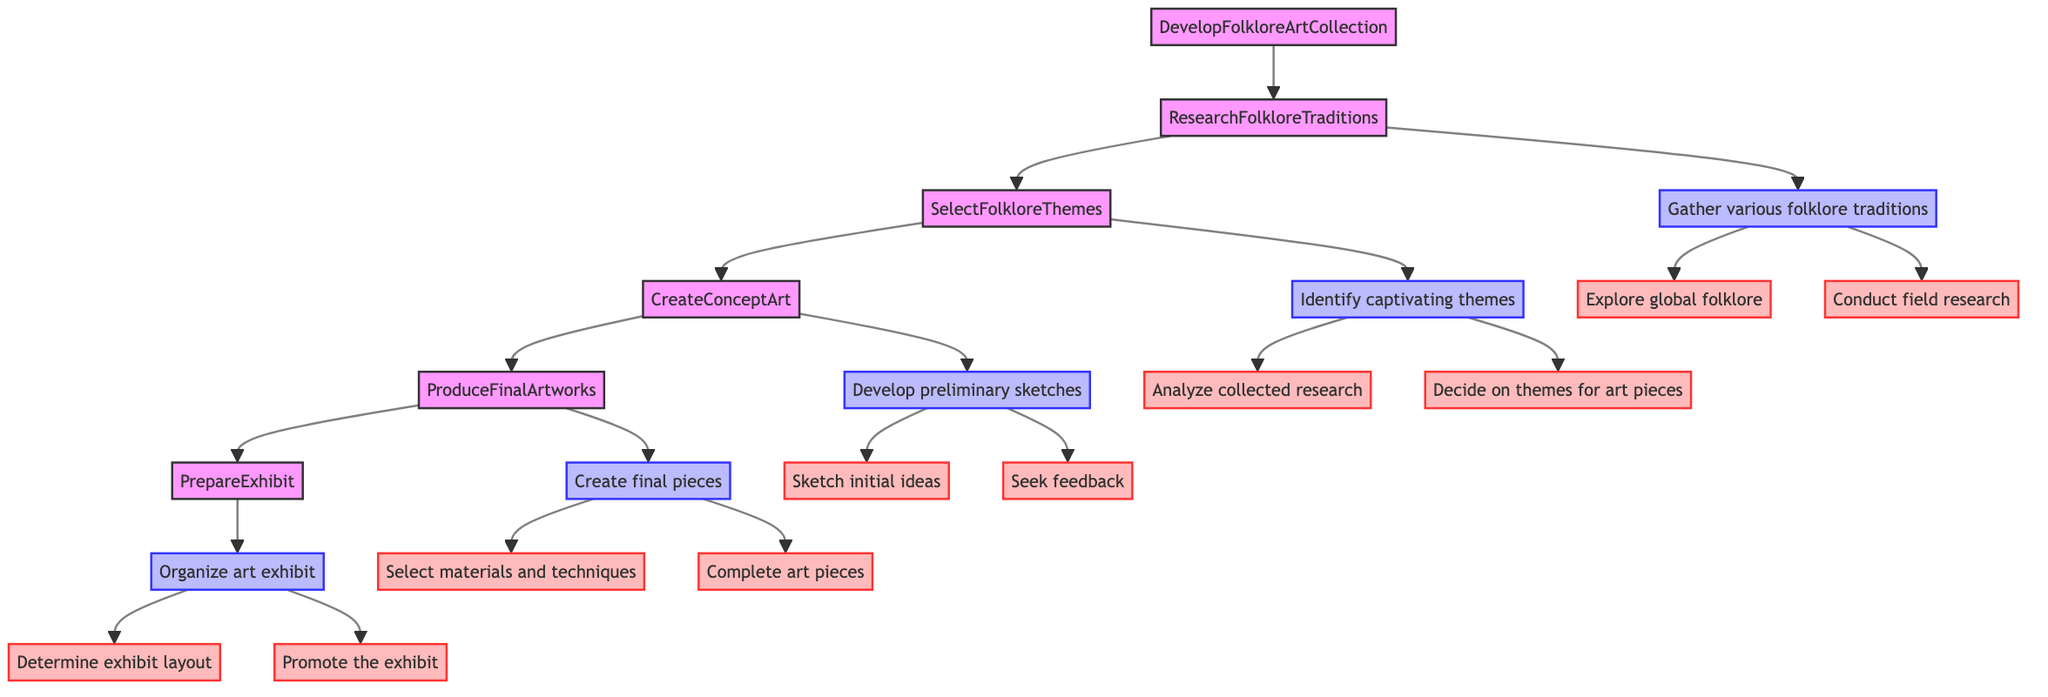What is the first step in developing a folklore art collection? The first step is "ResearchFolkloreTraditions," which is depicted as the first node following the main node "DevelopFolkloreArtCollection."
Answer: ResearchFolkloreTraditions How many actions are there under "ResearchFolkloreTraditions"? There are two main actions listed under "ResearchFolkloreTraditions": "Explore global folklore" and "Conduct field research."
Answer: 2 What theme is an example for "Decide on themes for art pieces"? One of the examples listed is "Japanese Yōkai spirits," found under "Decide on themes for art pieces."
Answer: Japanese Yōkai spirits What is the last action in the flowchart? The last action is "Promote the exhibit," which is the final step in preparing the exhibit.
Answer: Promote the exhibit What are the two methods for "Sketch initial ideas"? The two methods identified for this action are "Draw rough sketches based on selected themes" and "Experiment with different artistic styles."
Answer: Draw rough sketches based on selected themes, Experiment with different artistic styles What is the relationship between "CreateConceptArt" and "ProduceFinalArtworks"? The node "CreateConceptArt" leads to "ProduceFinalArtworks," indicating a sequential relationship where the creation of concept art precedes the production of final artworks.
Answer: Sequential relationship How many nodes are connected to "PrepareExhibit"? Three nodes are connected to "PrepareExhibit": "Organize art exhibit," "Determine exhibit layout," and "Promote the exhibit."
Answer: 3 What action follows after "Select materials and techniques"? The action that follows is "Complete art pieces," completing the phase of producing final artworks.
Answer: Complete art pieces What is required in the "Gather various folklore traditions" step? This step requires exploring global folklore and conducting field research according to its connected actions.
Answer: Explore global folklore, Conduct field research 